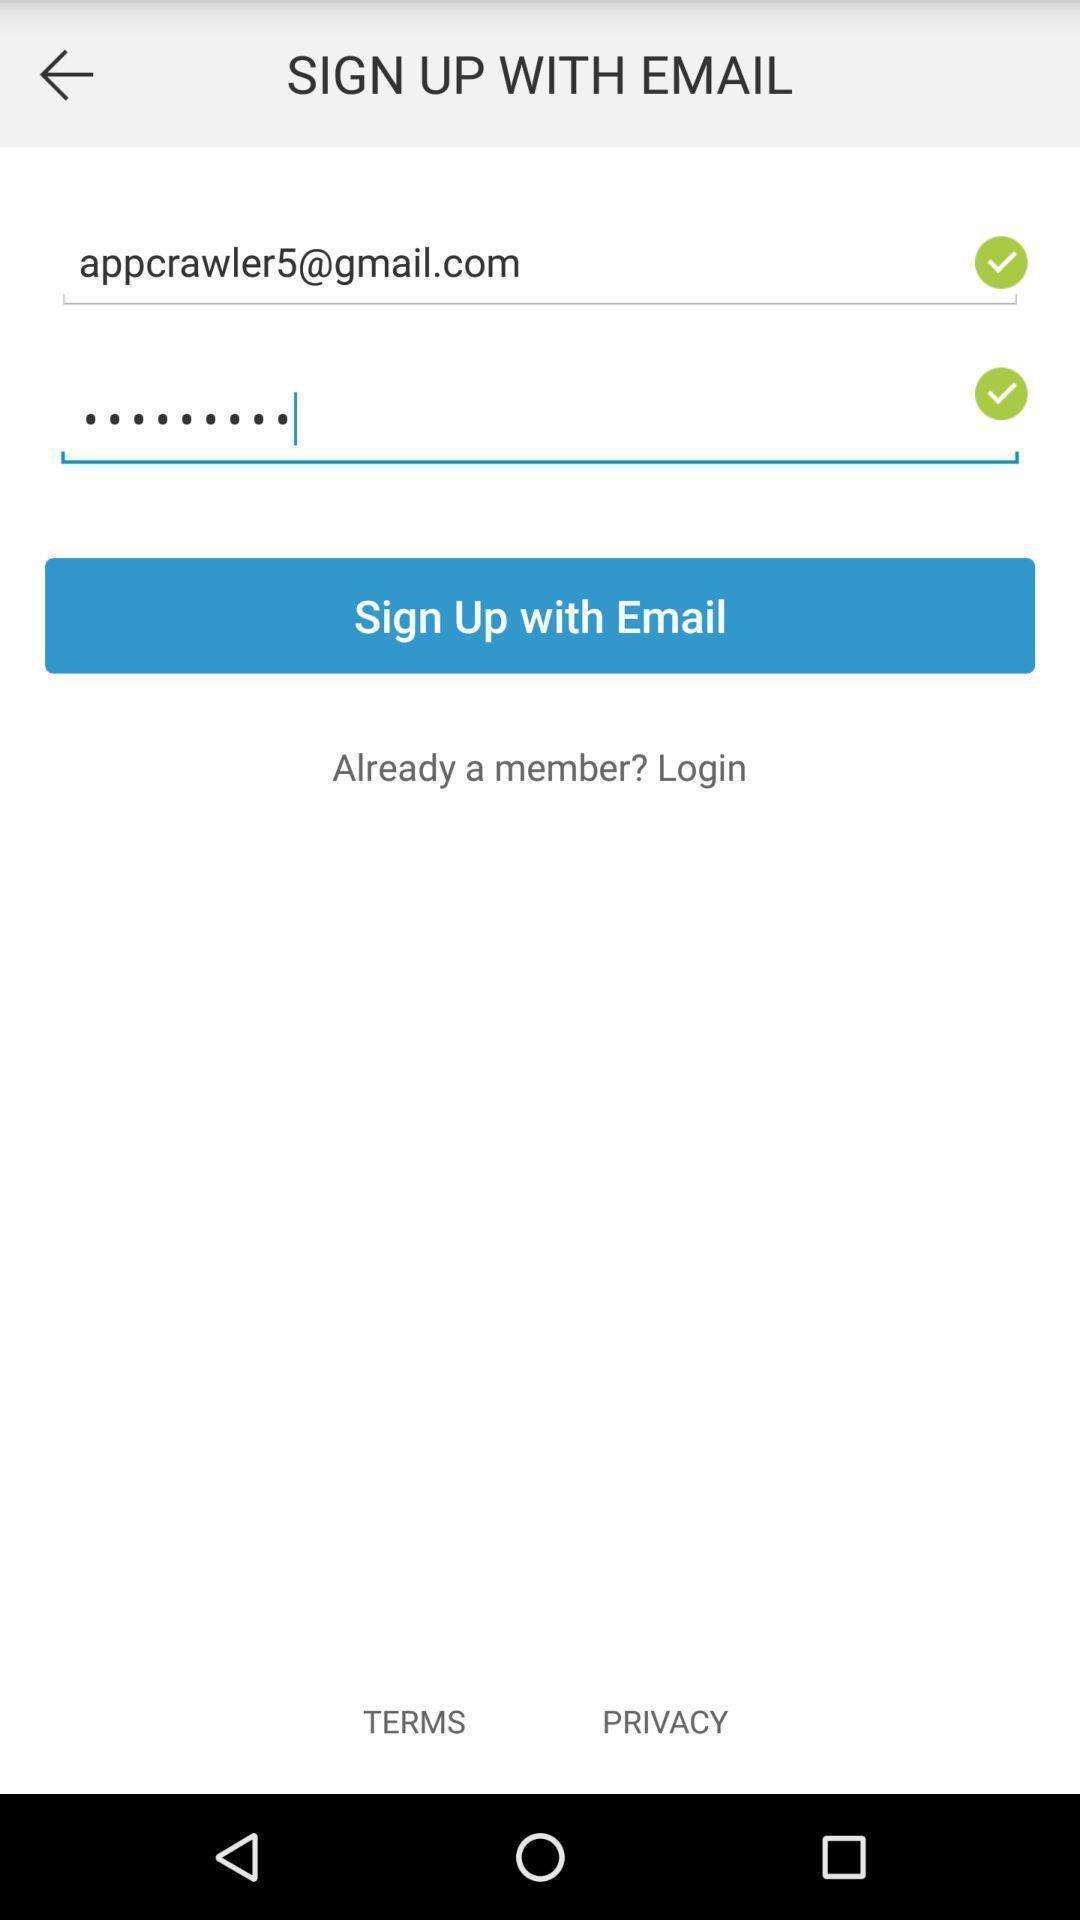What can you discern from this picture? Sign up page. 